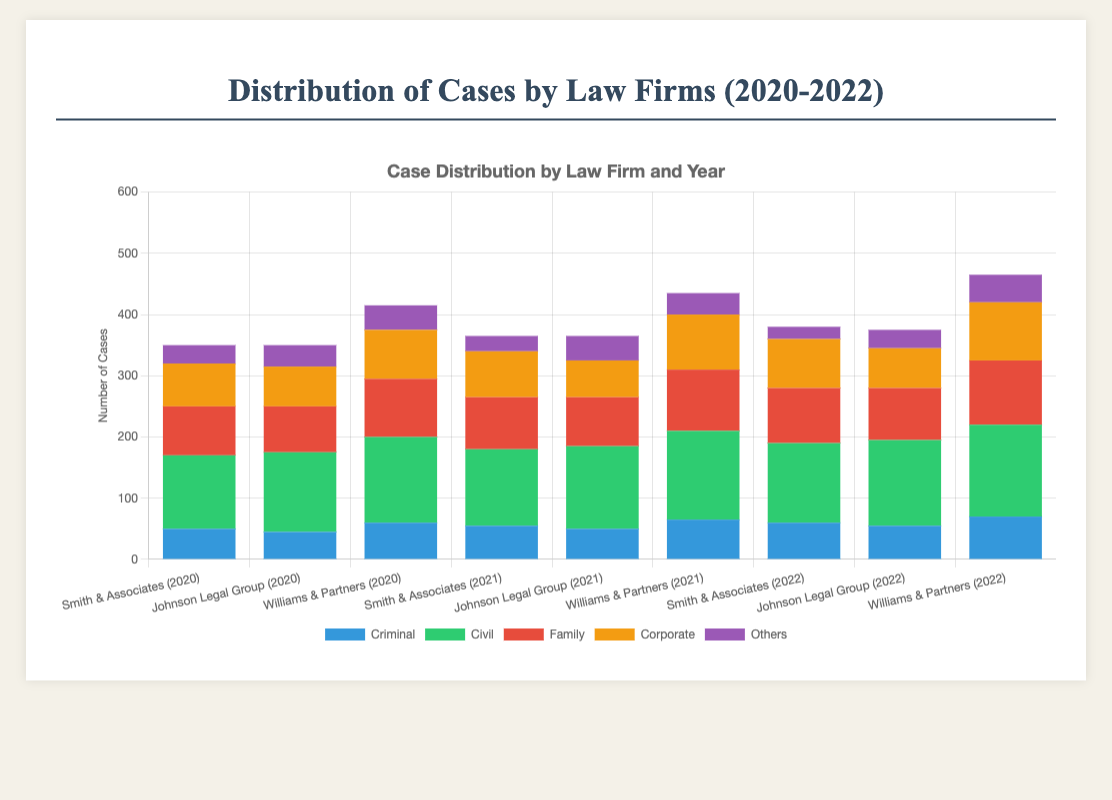Which law firm handled the most cases in 2022? To find the firm handling the most cases, sum criminal, civil, family, corporate, and others for each firm in 2022. For Smith & Associates, it's (60 + 130 + 90 + 80 + 20) = 380. For Johnson Legal Group, it's (55 + 140 + 85 + 65 + 30) = 375. For Williams & Partners, it's (70 + 150 + 105 + 95 + 45) = 465. Williams & Partners handled the most cases.
Answer: Williams & Partners How did the number of civil cases handled by Johnson Legal Group change from 2020 to 2022? Compare civil cases handled by Johnson Legal Group for each year: 2020 (130), 2021 (135), and 2022 (140). The cases increased by 5 from 2020 to 2021 and by another 5 from 2021 to 2022. Overall, it increased by 10 from 2020 to 2022.
Answer: Increased by 10 What was the combined total of family cases handled by all firms in 2021? Sum family cases across all firms in 2021: Smith & Associates (85), Johnson Legal Group (80), and Williams & Partners (100). So, 85 + 80 + 100 = 265.
Answer: 265 Which type of case saw the most significant increase for Smith & Associates from 2020 to 2022? Calculate the differences for each case type: Criminal (60-50)=10, Civil (130-120)=10, Family (90-80)=10, Corporate (80-70)=10, Others (20-30)=-10. All increases are 10 except Others which declined. There is no single most significant increase.
Answer: Criminal, Civil, Family, Corporate Which year had the highest number of combined criminal cases for all law firms? Sum the criminal cases by year: 2020 (50+45+60)=155, 2021 (55+50+65)=170, 2022 (60+55+70)=185. The year 2022 had the highest combined criminal cases.
Answer: 2022 What is the difference in total corporate cases between Williams & Partners and Johnson Legal Group over the three years? Sum corporate cases for Williams & Partners: 2020 (80), 2021 (90), 2022 (95). Total = 80 + 90 + 95 = 265. Sum corporate cases for Johnson Legal Group: 2020 (65), 2021 (60), 2022 (65). Total = 65 + 60 + 65 = 190. Difference is 265 - 190 = 75.
Answer: 75 